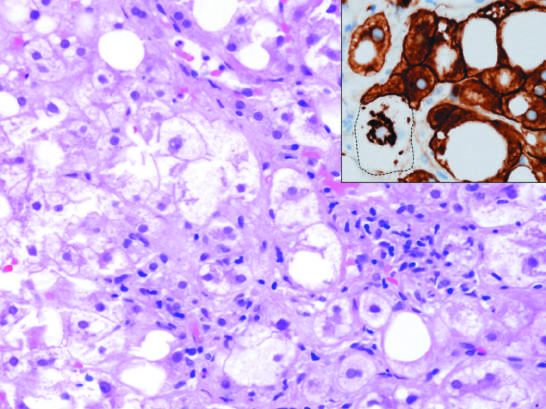what does the inset stained for keratins 8 and 18 (brown) show?
Answer the question using a single word or phrase. A ballooned cell in which keratins have been ubiquitinylated and have collapsed into an immunoreactive mallory-denk body 